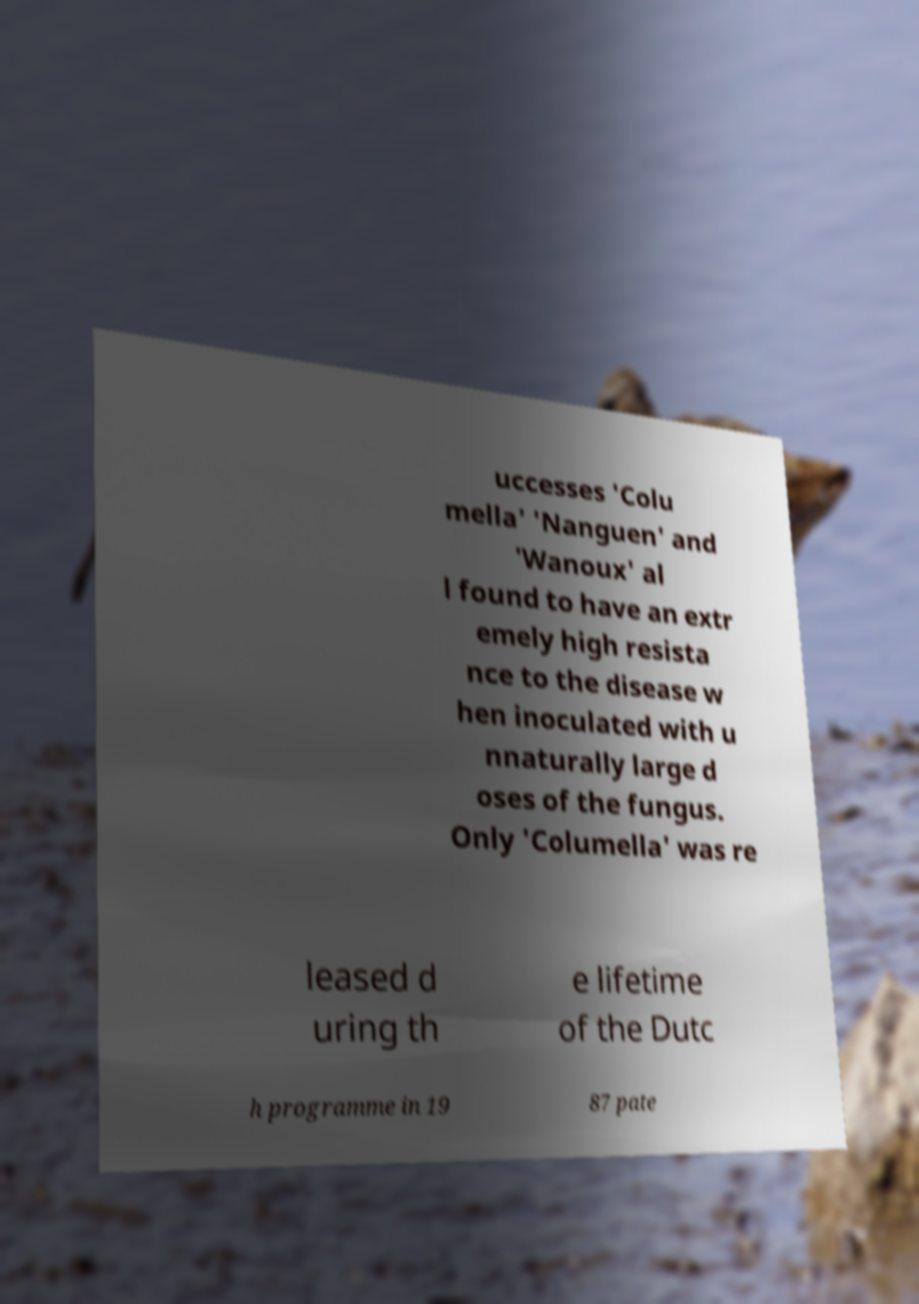Could you extract and type out the text from this image? uccesses 'Colu mella' 'Nanguen' and 'Wanoux' al l found to have an extr emely high resista nce to the disease w hen inoculated with u nnaturally large d oses of the fungus. Only 'Columella' was re leased d uring th e lifetime of the Dutc h programme in 19 87 pate 